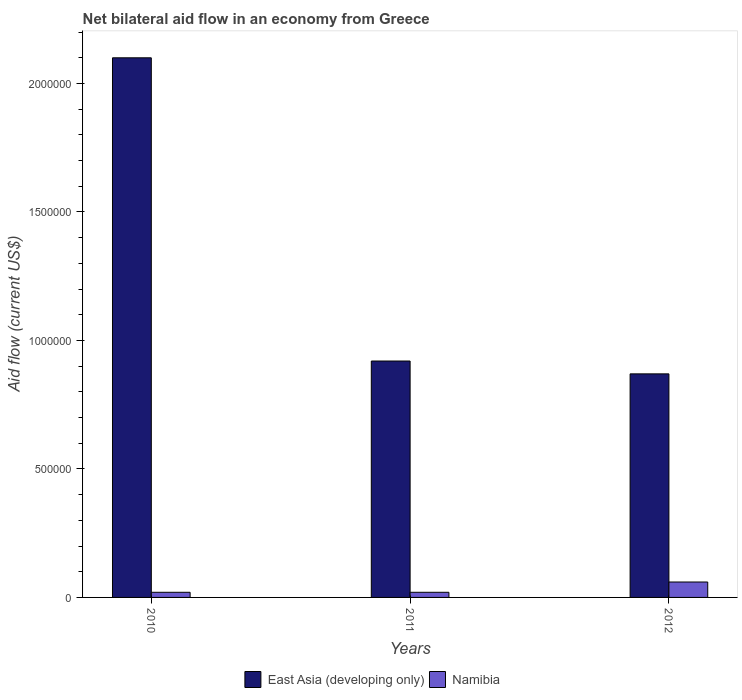How many groups of bars are there?
Keep it short and to the point. 3. Are the number of bars per tick equal to the number of legend labels?
Ensure brevity in your answer.  Yes. Are the number of bars on each tick of the X-axis equal?
Make the answer very short. Yes. How many bars are there on the 1st tick from the right?
Your response must be concise. 2. What is the net bilateral aid flow in East Asia (developing only) in 2012?
Your answer should be compact. 8.70e+05. Across all years, what is the maximum net bilateral aid flow in East Asia (developing only)?
Make the answer very short. 2.10e+06. Across all years, what is the minimum net bilateral aid flow in East Asia (developing only)?
Give a very brief answer. 8.70e+05. In which year was the net bilateral aid flow in East Asia (developing only) maximum?
Keep it short and to the point. 2010. In which year was the net bilateral aid flow in East Asia (developing only) minimum?
Ensure brevity in your answer.  2012. What is the difference between the net bilateral aid flow in East Asia (developing only) in 2010 and that in 2012?
Keep it short and to the point. 1.23e+06. What is the difference between the net bilateral aid flow in Namibia in 2010 and the net bilateral aid flow in East Asia (developing only) in 2012?
Keep it short and to the point. -8.50e+05. What is the average net bilateral aid flow in Namibia per year?
Ensure brevity in your answer.  3.33e+04. In the year 2011, what is the difference between the net bilateral aid flow in Namibia and net bilateral aid flow in East Asia (developing only)?
Provide a succinct answer. -9.00e+05. What is the ratio of the net bilateral aid flow in Namibia in 2010 to that in 2011?
Offer a terse response. 1. Is the difference between the net bilateral aid flow in Namibia in 2010 and 2012 greater than the difference between the net bilateral aid flow in East Asia (developing only) in 2010 and 2012?
Keep it short and to the point. No. What is the difference between the highest and the second highest net bilateral aid flow in East Asia (developing only)?
Offer a very short reply. 1.18e+06. What is the difference between the highest and the lowest net bilateral aid flow in East Asia (developing only)?
Ensure brevity in your answer.  1.23e+06. Is the sum of the net bilateral aid flow in Namibia in 2011 and 2012 greater than the maximum net bilateral aid flow in East Asia (developing only) across all years?
Give a very brief answer. No. What does the 1st bar from the left in 2010 represents?
Provide a short and direct response. East Asia (developing only). What does the 2nd bar from the right in 2012 represents?
Your answer should be very brief. East Asia (developing only). How many years are there in the graph?
Keep it short and to the point. 3. What is the difference between two consecutive major ticks on the Y-axis?
Keep it short and to the point. 5.00e+05. Are the values on the major ticks of Y-axis written in scientific E-notation?
Make the answer very short. No. Does the graph contain any zero values?
Give a very brief answer. No. Does the graph contain grids?
Your answer should be very brief. No. How many legend labels are there?
Offer a terse response. 2. How are the legend labels stacked?
Offer a terse response. Horizontal. What is the title of the graph?
Offer a very short reply. Net bilateral aid flow in an economy from Greece. What is the label or title of the X-axis?
Ensure brevity in your answer.  Years. What is the Aid flow (current US$) in East Asia (developing only) in 2010?
Give a very brief answer. 2.10e+06. What is the Aid flow (current US$) in East Asia (developing only) in 2011?
Ensure brevity in your answer.  9.20e+05. What is the Aid flow (current US$) of East Asia (developing only) in 2012?
Your answer should be very brief. 8.70e+05. Across all years, what is the maximum Aid flow (current US$) in East Asia (developing only)?
Offer a very short reply. 2.10e+06. Across all years, what is the maximum Aid flow (current US$) in Namibia?
Offer a terse response. 6.00e+04. Across all years, what is the minimum Aid flow (current US$) in East Asia (developing only)?
Provide a short and direct response. 8.70e+05. What is the total Aid flow (current US$) in East Asia (developing only) in the graph?
Give a very brief answer. 3.89e+06. What is the total Aid flow (current US$) in Namibia in the graph?
Make the answer very short. 1.00e+05. What is the difference between the Aid flow (current US$) in East Asia (developing only) in 2010 and that in 2011?
Provide a short and direct response. 1.18e+06. What is the difference between the Aid flow (current US$) of East Asia (developing only) in 2010 and that in 2012?
Provide a succinct answer. 1.23e+06. What is the difference between the Aid flow (current US$) in Namibia in 2010 and that in 2012?
Provide a short and direct response. -4.00e+04. What is the difference between the Aid flow (current US$) of East Asia (developing only) in 2011 and that in 2012?
Offer a very short reply. 5.00e+04. What is the difference between the Aid flow (current US$) of Namibia in 2011 and that in 2012?
Your answer should be very brief. -4.00e+04. What is the difference between the Aid flow (current US$) of East Asia (developing only) in 2010 and the Aid flow (current US$) of Namibia in 2011?
Your response must be concise. 2.08e+06. What is the difference between the Aid flow (current US$) in East Asia (developing only) in 2010 and the Aid flow (current US$) in Namibia in 2012?
Keep it short and to the point. 2.04e+06. What is the difference between the Aid flow (current US$) of East Asia (developing only) in 2011 and the Aid flow (current US$) of Namibia in 2012?
Provide a short and direct response. 8.60e+05. What is the average Aid flow (current US$) in East Asia (developing only) per year?
Your answer should be very brief. 1.30e+06. What is the average Aid flow (current US$) in Namibia per year?
Your answer should be very brief. 3.33e+04. In the year 2010, what is the difference between the Aid flow (current US$) of East Asia (developing only) and Aid flow (current US$) of Namibia?
Your response must be concise. 2.08e+06. In the year 2011, what is the difference between the Aid flow (current US$) of East Asia (developing only) and Aid flow (current US$) of Namibia?
Offer a terse response. 9.00e+05. In the year 2012, what is the difference between the Aid flow (current US$) in East Asia (developing only) and Aid flow (current US$) in Namibia?
Your response must be concise. 8.10e+05. What is the ratio of the Aid flow (current US$) of East Asia (developing only) in 2010 to that in 2011?
Ensure brevity in your answer.  2.28. What is the ratio of the Aid flow (current US$) in East Asia (developing only) in 2010 to that in 2012?
Ensure brevity in your answer.  2.41. What is the ratio of the Aid flow (current US$) in Namibia in 2010 to that in 2012?
Your response must be concise. 0.33. What is the ratio of the Aid flow (current US$) of East Asia (developing only) in 2011 to that in 2012?
Keep it short and to the point. 1.06. What is the difference between the highest and the second highest Aid flow (current US$) of East Asia (developing only)?
Provide a succinct answer. 1.18e+06. What is the difference between the highest and the second highest Aid flow (current US$) of Namibia?
Provide a short and direct response. 4.00e+04. What is the difference between the highest and the lowest Aid flow (current US$) in East Asia (developing only)?
Your answer should be very brief. 1.23e+06. What is the difference between the highest and the lowest Aid flow (current US$) in Namibia?
Keep it short and to the point. 4.00e+04. 